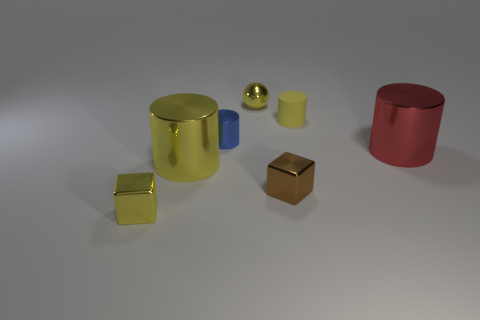Subtract all small blue cylinders. How many cylinders are left? 3 Subtract 4 cylinders. How many cylinders are left? 0 Subtract all brown blocks. How many blocks are left? 1 Subtract all purple blocks. Subtract all blue spheres. How many blocks are left? 2 Subtract all green spheres. How many cyan cubes are left? 0 Subtract all yellow balls. Subtract all red metal cylinders. How many objects are left? 5 Add 6 brown cubes. How many brown cubes are left? 7 Add 3 metallic balls. How many metallic balls exist? 4 Add 2 green matte balls. How many objects exist? 9 Subtract 0 cyan balls. How many objects are left? 7 